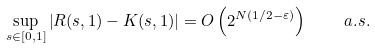Convert formula to latex. <formula><loc_0><loc_0><loc_500><loc_500>\sup _ { s \in [ 0 , 1 ] } \left | R ( s , 1 ) - K ( s , 1 ) \right | = O \left ( 2 ^ { N ( 1 / 2 - \varepsilon ) } \right ) \quad a . s .</formula> 